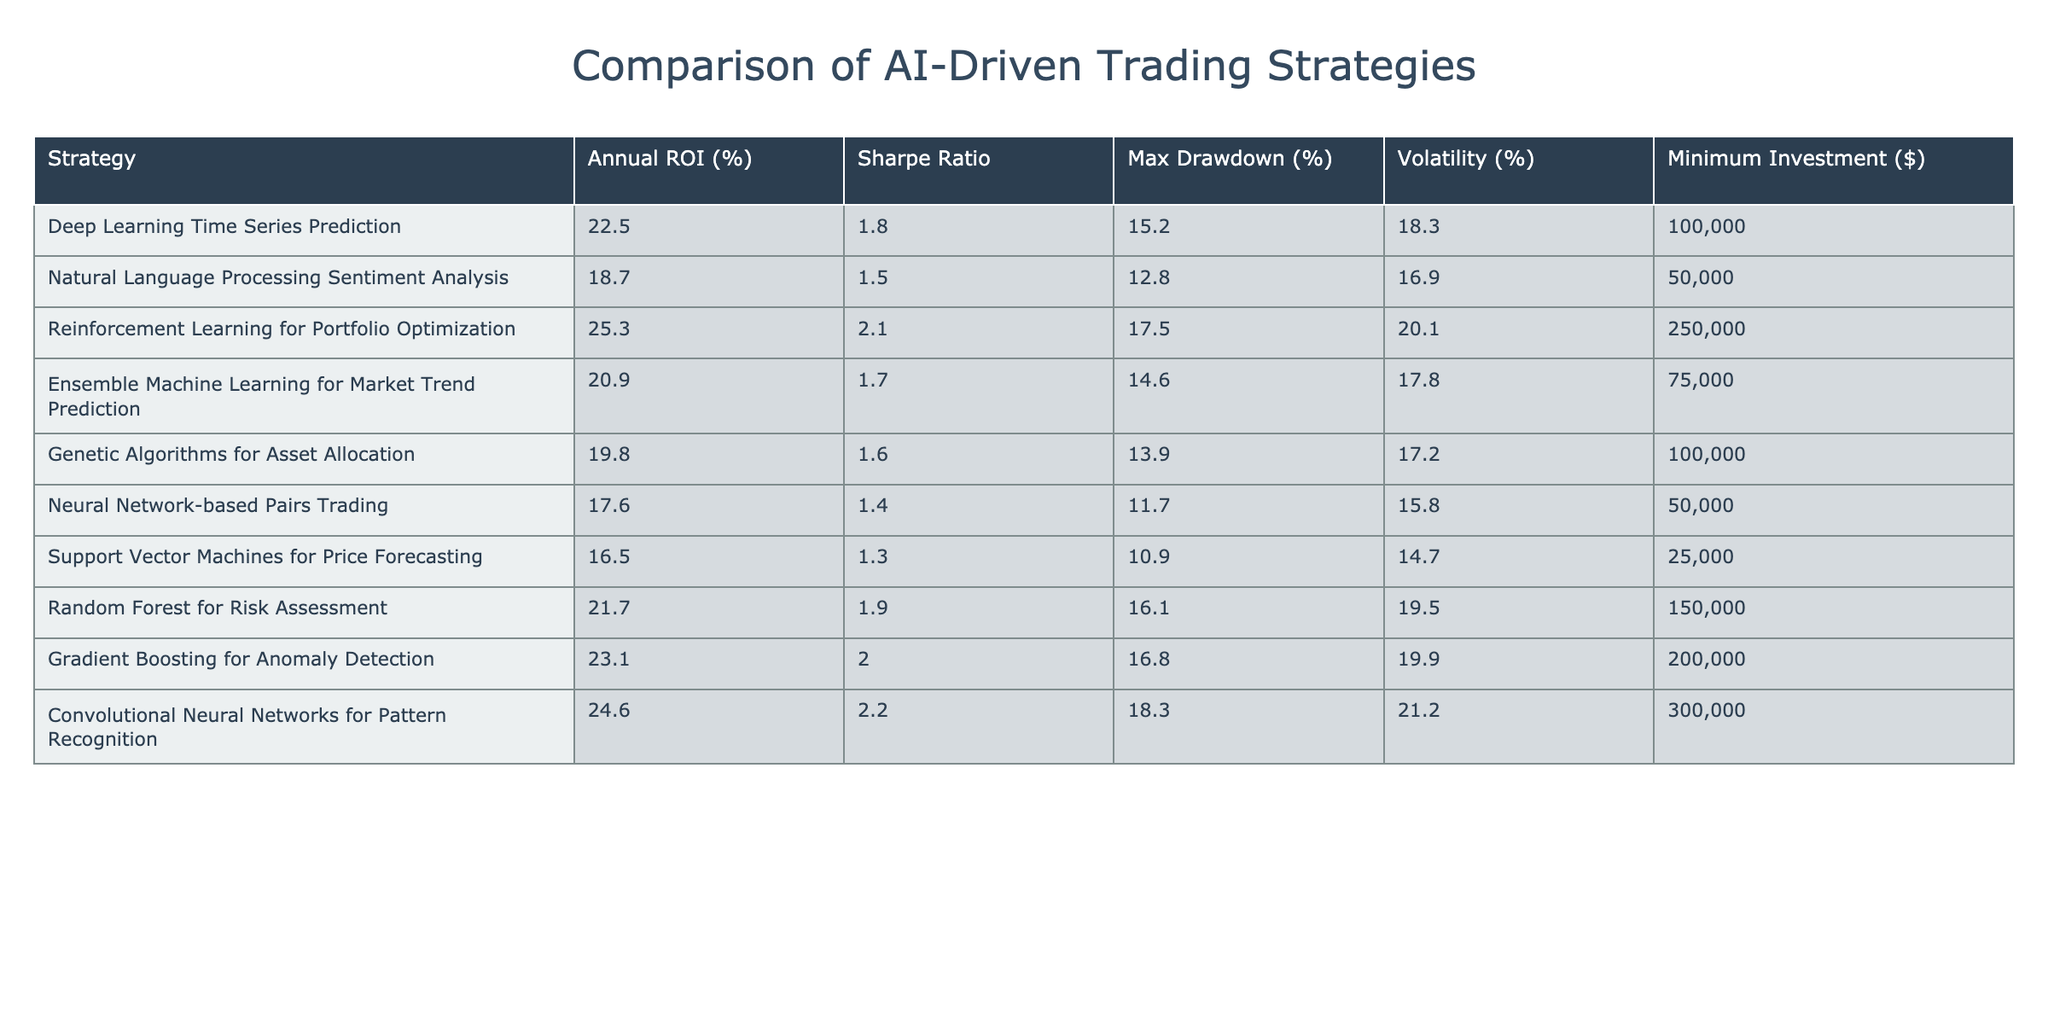What is the highest Annual ROI among the listed strategies? Looking at the "Annual ROI (%)" column, the values are 22.5, 18.7, 25.3, 20.9, 19.8, 17.6, 16.5, 21.7, 23.1, and 24.6. The maximum value is 25.3, which corresponds to the "Reinforcement Learning for Portfolio Optimization" strategy.
Answer: 25.3 Which strategy has the lowest Max Drawdown? By examining the "Max Drawdown (%)" column, the values are 15.2, 12.8, 17.5, 14.6, 13.9, 11.7, 10.9, 16.1, 16.8, and 18.3. The minimum value is 10.9, which corresponds to the "Support Vector Machines for Price Forecasting" strategy.
Answer: Support Vector Machines for Price Forecasting What is the average Sharpe Ratio of all strategies? The Sharpe Ratios are 1.8, 1.5, 2.1, 1.7, 1.6, 1.4, 1.3, 1.9, 2.0, and 2.2. Summing these gives 1.8 + 1.5 + 2.1 + 1.7 + 1.6 + 1.4 + 1.3 + 1.9 + 2.0 + 2.2 = 18.6. There are 10 strategies, so the average is 18.6 / 10 = 1.86.
Answer: 1.86 Is there any strategy that requires a minimum investment of less than $50,000? In the "Minimum Investment ($)" column, the values are 100000, 50000, 250000, 75000, 100000, 50000, 25000, 150000, 200000, and 300000. The lowest value is 25000, indicating that there is indeed a strategy ("Support Vector Machines for Price Forecasting") that requires less than $50,000.
Answer: Yes Which strategy has the highest combination of ROI and Sharpe Ratio? To find the best combination of ROI and Sharpe Ratio, we calculate ROI × Sharpe Ratio for each strategy. The respective values are: 22.5 × 1.8 = 40.5, 18.7 × 1.5 = 28.05, 25.3 × 2.1 = 53.13, 20.9 × 1.7 = 35.53, 19.8 × 1.6 = 31.68, 17.6 × 1.4 = 24.64, 16.5 × 1.3 = 21.45, 21.7 × 1.9 = 41.23, 23.1 × 2.0 = 46.2, and 24.6 × 2.2 = 54.12. The maximum value calculated is 54.12 for "Convolutional Neural Networks for Pattern Recognition."
Answer: Convolutional Neural Networks for Pattern Recognition 